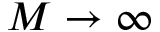<formula> <loc_0><loc_0><loc_500><loc_500>M \rightarrow \infty</formula> 